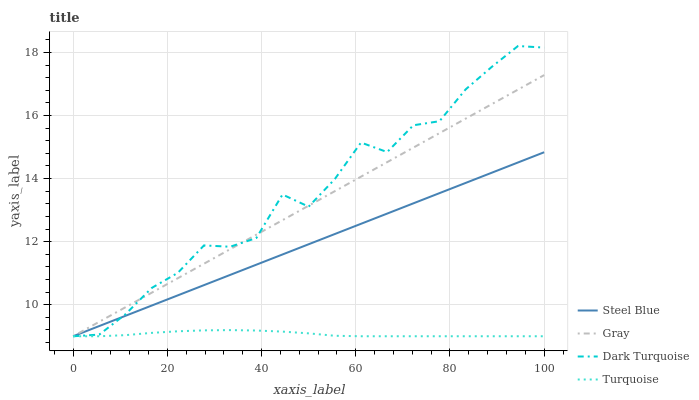Does Turquoise have the minimum area under the curve?
Answer yes or no. Yes. Does Dark Turquoise have the maximum area under the curve?
Answer yes or no. Yes. Does Steel Blue have the minimum area under the curve?
Answer yes or no. No. Does Steel Blue have the maximum area under the curve?
Answer yes or no. No. Is Gray the smoothest?
Answer yes or no. Yes. Is Dark Turquoise the roughest?
Answer yes or no. Yes. Is Turquoise the smoothest?
Answer yes or no. No. Is Turquoise the roughest?
Answer yes or no. No. Does Dark Turquoise have the highest value?
Answer yes or no. Yes. Does Steel Blue have the highest value?
Answer yes or no. No. 